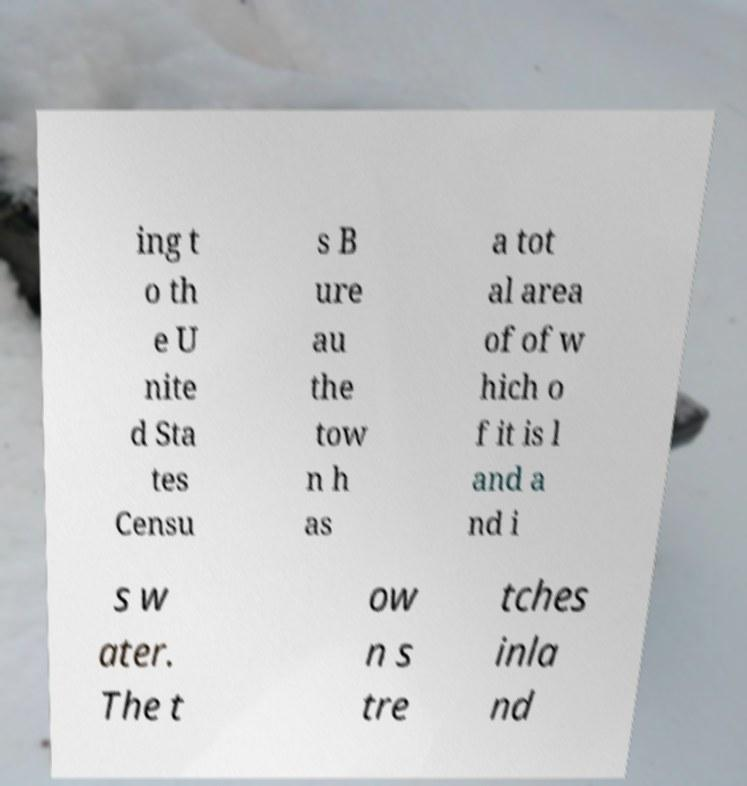For documentation purposes, I need the text within this image transcribed. Could you provide that? ing t o th e U nite d Sta tes Censu s B ure au the tow n h as a tot al area of of w hich o f it is l and a nd i s w ater. The t ow n s tre tches inla nd 